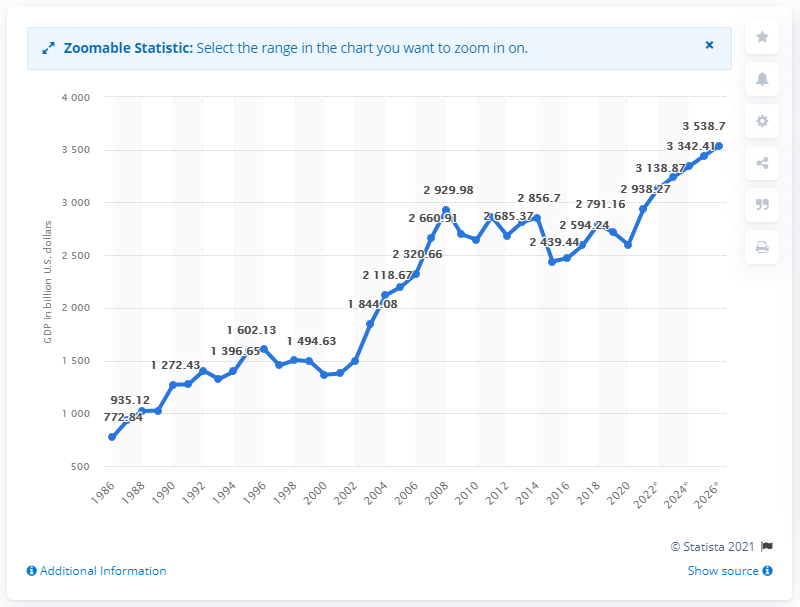Outline some significant characteristics in this image. In 2020, the Gross Domestic Product (GDP) of France was 2598.91 billion U.S. dollars. 